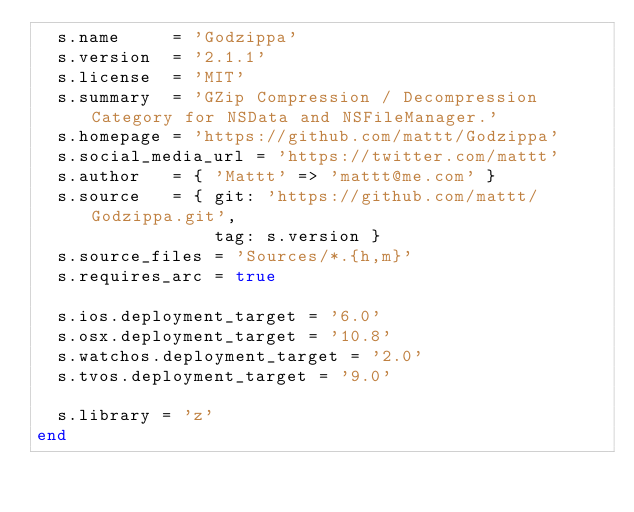<code> <loc_0><loc_0><loc_500><loc_500><_Ruby_>  s.name     = 'Godzippa'
  s.version  = '2.1.1'
  s.license  = 'MIT'
  s.summary  = 'GZip Compression / Decompression Category for NSData and NSFileManager.'
  s.homepage = 'https://github.com/mattt/Godzippa'
  s.social_media_url = 'https://twitter.com/mattt'
  s.author   = { 'Mattt' => 'mattt@me.com' }
  s.source   = { git: 'https://github.com/mattt/Godzippa.git',
                 tag: s.version }
  s.source_files = 'Sources/*.{h,m}'
  s.requires_arc = true

  s.ios.deployment_target = '6.0'
  s.osx.deployment_target = '10.8'
  s.watchos.deployment_target = '2.0'
  s.tvos.deployment_target = '9.0'

  s.library = 'z'
end
</code> 